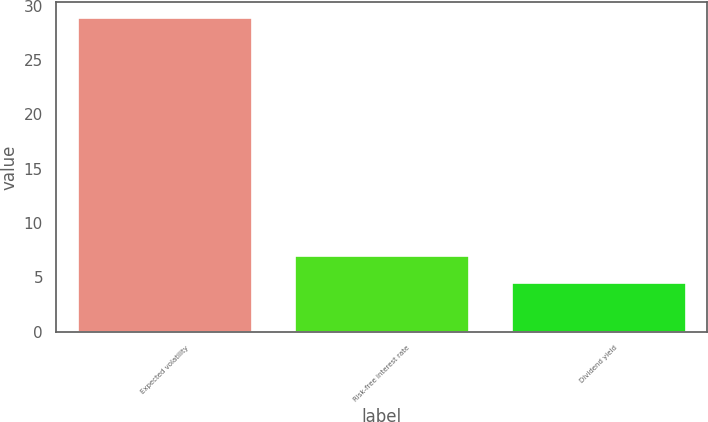<chart> <loc_0><loc_0><loc_500><loc_500><bar_chart><fcel>Expected volatility<fcel>Risk-free interest rate<fcel>Dividend yield<nl><fcel>28.9<fcel>6.94<fcel>4.5<nl></chart> 